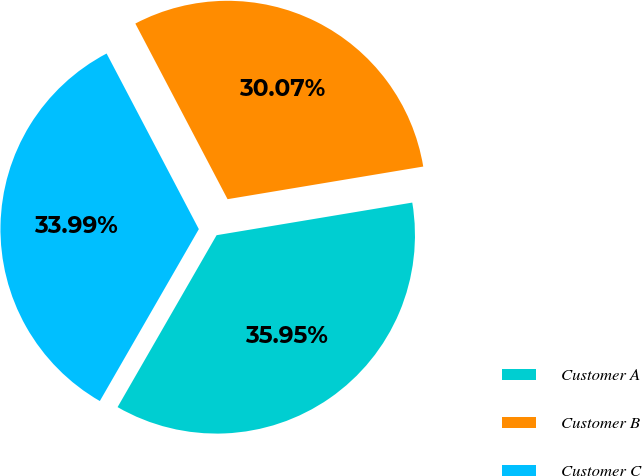Convert chart to OTSL. <chart><loc_0><loc_0><loc_500><loc_500><pie_chart><fcel>Customer A<fcel>Customer B<fcel>Customer C<nl><fcel>35.95%<fcel>30.07%<fcel>33.99%<nl></chart> 